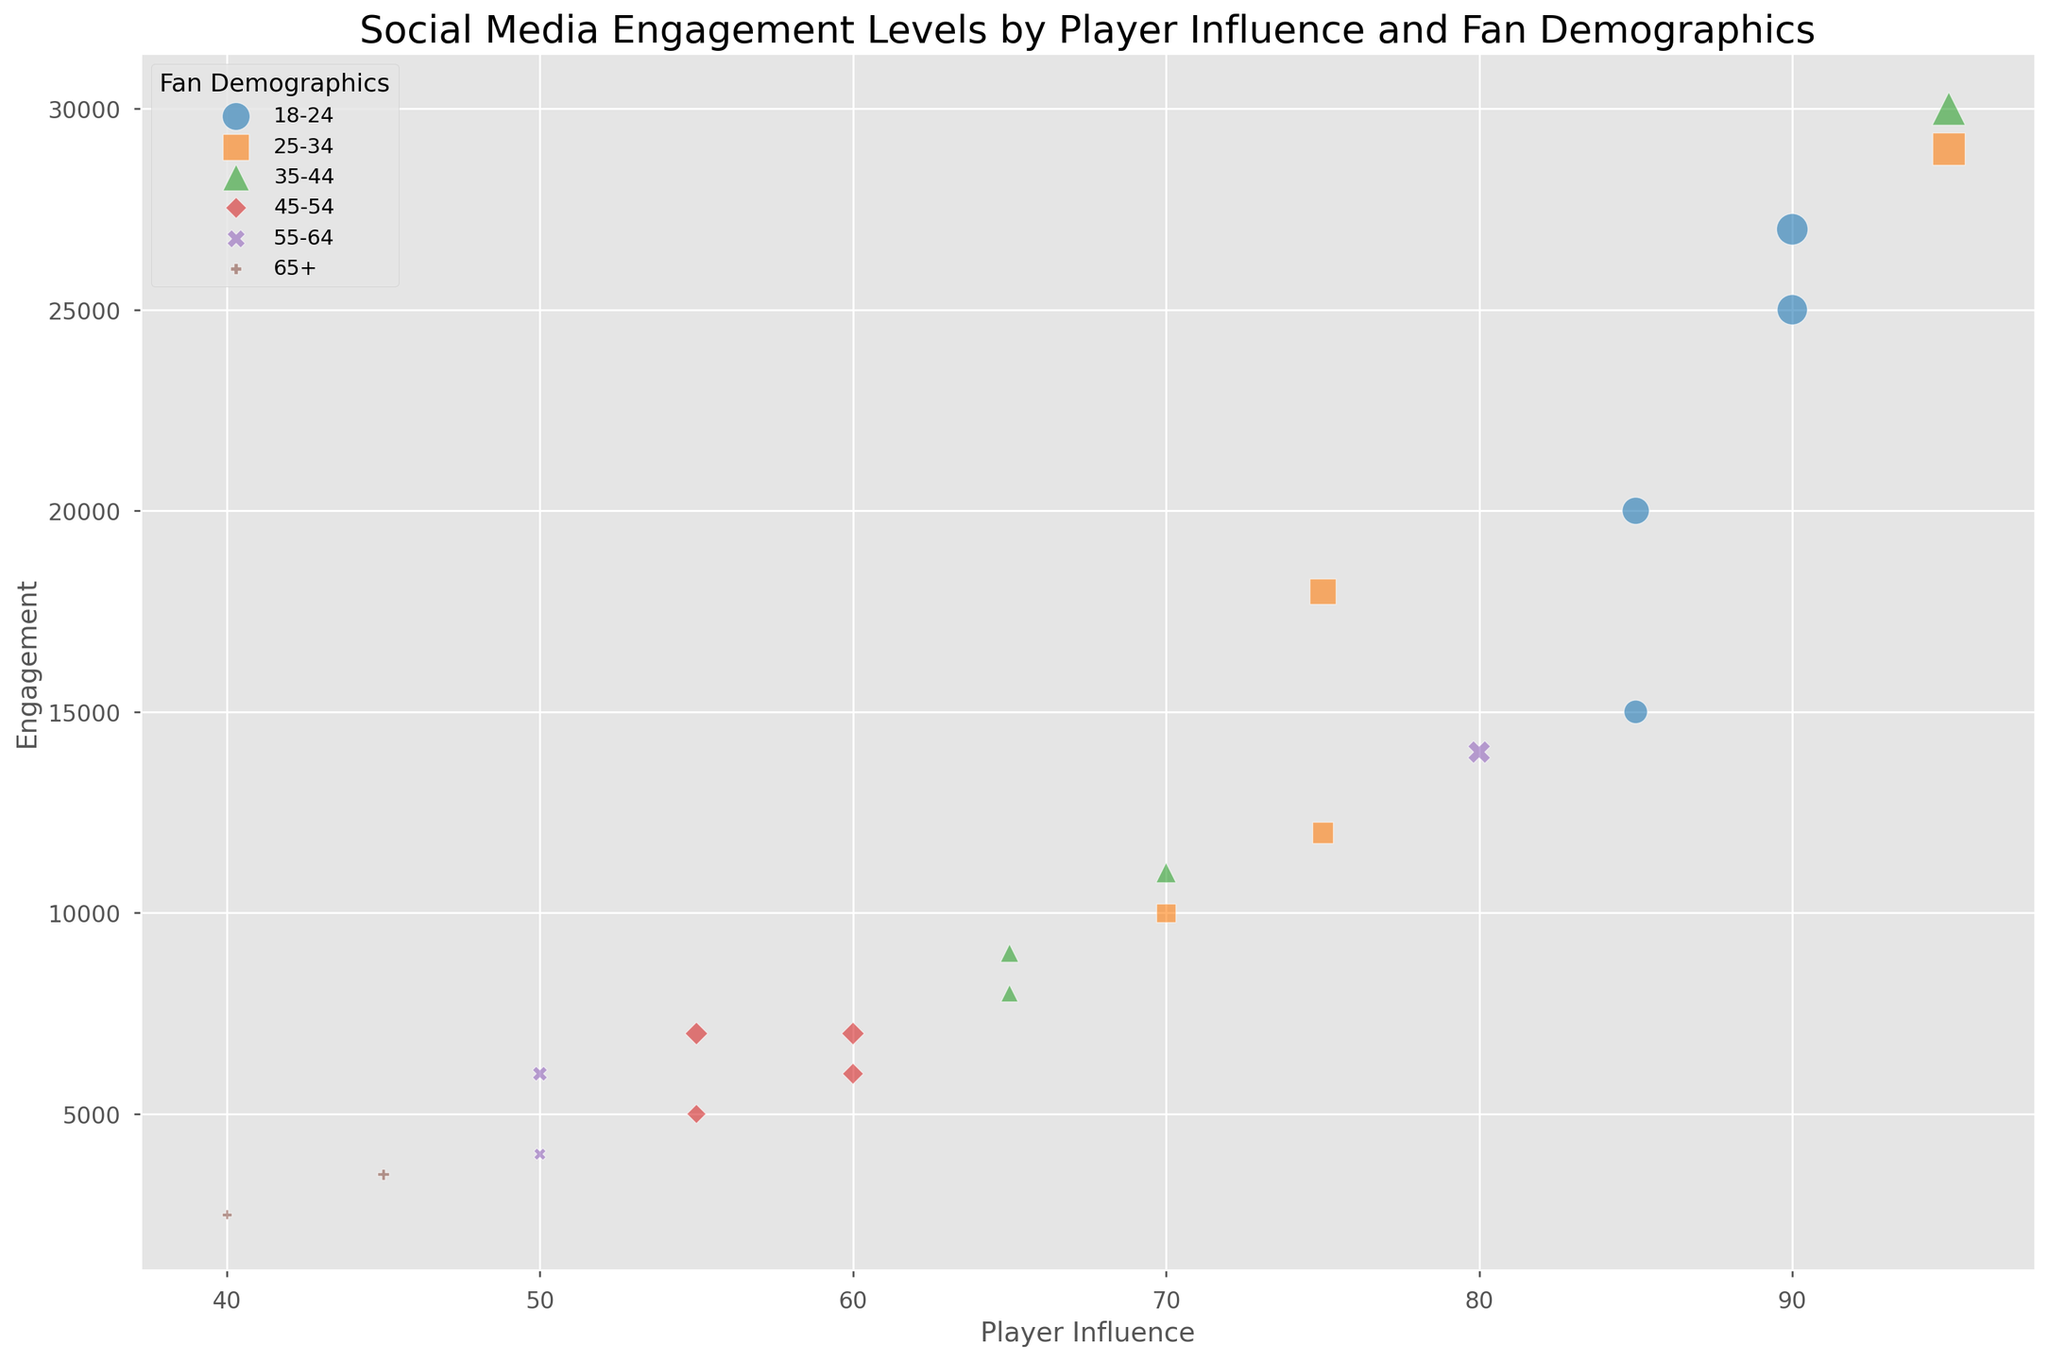Which player has the highest social media engagement? By examining the vertical axis for the highest value, we see that Alex Johnson has the greatest engagement at 30,000.
Answer: Alex Johnson Which fan demographic appears to have the most players with high influence? Observing the horizontal axis and the scatter's color, we notice that the '18-24' demographic has several players with influence scores above 85, including John Doe, Jane Smith, Blake Anderson, and Parker Evans.
Answer: 18-24 Compare the engagement levels between the '35-44' and '65+' demographics. Which has higher engagement on average? Calculate the average engagement for each group. '35-44': (8000 + 30000 + 9000 + 11000) / 4 = 14500. '65+': (3500 + 2500) / 2 = 3000. The '35-44' group has a higher average engagement.
Answer: 35-44 Which player has the least engagement in the '45-54' demographic? Among the players in the '45-54' demographic, Taylor Williams has the lowest engagement at 5000.
Answer: Taylor Williams How does Chris Green's engagement compare to Taylor Williams' engagement? Chris Green has an engagement level of 8000, while Taylor Williams has an engagement level of 5000. Chris Green's engagement is higher than Taylor Williams'.
Answer: Higher Which demographic has the most varied (widest range of) engagement levels? Consider each demographic's maximum and minimum engagement levels. '18-24': (30000 - 15000), '25-34': (29000 - 10000), '35-44': (30000 - 8000), '45-54': (7000 - 5000), '55-64': (14000 - 4000), '65+': (3500 - 2500). The '35-44' demographic has the widest range of engagement levels with a range of 30000 - 8000 = 22000.
Answer: 35-44 Is John Doe's engagement greater than the median engagement of players aged 18-24? First, list the engagement for '18-24' players: 15000, 25000, 20000, 27000. The median is the average of the middle values (20000 + 25000)/2 = 22500. John Doe's engagement is 15000, which is less than the median of 22500.
Answer: No How many players are from the '55-64' demographic, and what is their average influence score? There are 3 players: Morgan Lee (80), Casey Carter (50), and Alex Scott (50). Average influence is (80 + 50 + 50) / 3 = 60.
Answer: 3 players; 60 